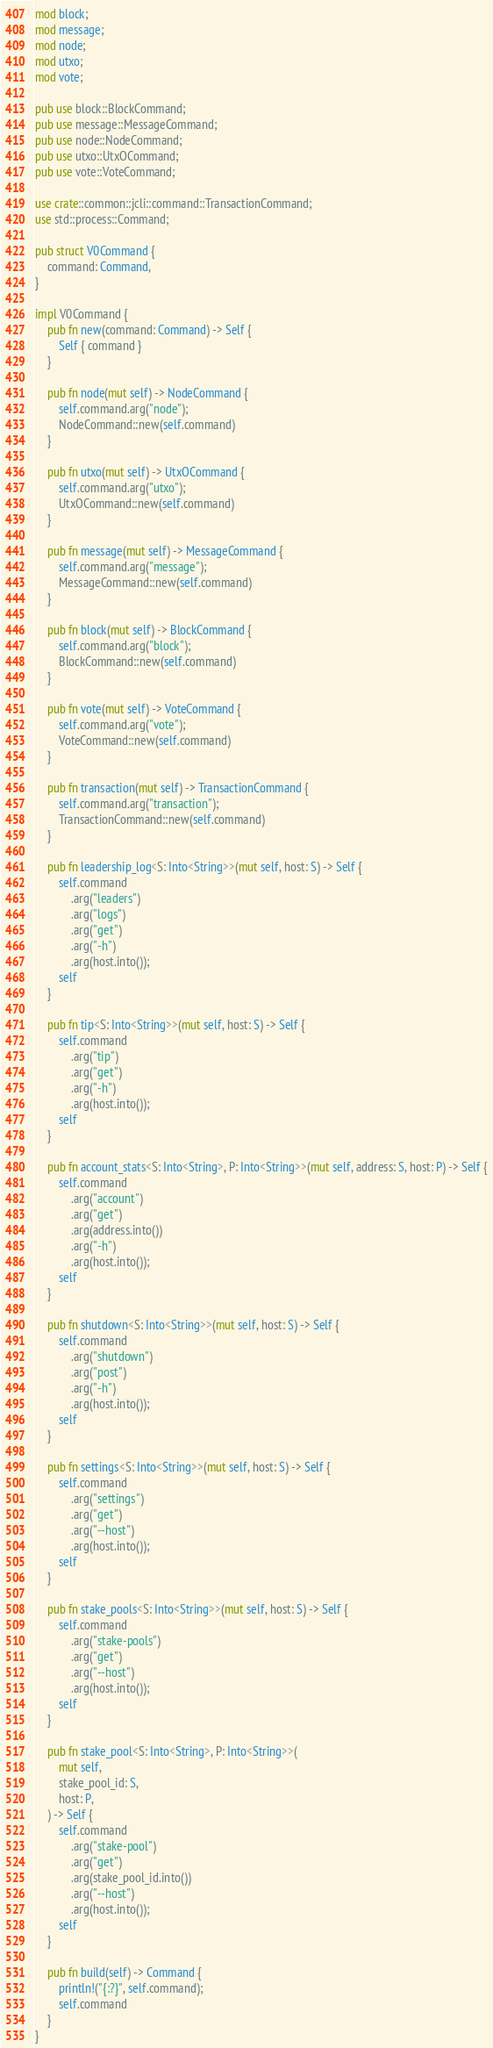Convert code to text. <code><loc_0><loc_0><loc_500><loc_500><_Rust_>mod block;
mod message;
mod node;
mod utxo;
mod vote;

pub use block::BlockCommand;
pub use message::MessageCommand;
pub use node::NodeCommand;
pub use utxo::UtxOCommand;
pub use vote::VoteCommand;

use crate::common::jcli::command::TransactionCommand;
use std::process::Command;

pub struct V0Command {
    command: Command,
}

impl V0Command {
    pub fn new(command: Command) -> Self {
        Self { command }
    }

    pub fn node(mut self) -> NodeCommand {
        self.command.arg("node");
        NodeCommand::new(self.command)
    }

    pub fn utxo(mut self) -> UtxOCommand {
        self.command.arg("utxo");
        UtxOCommand::new(self.command)
    }

    pub fn message(mut self) -> MessageCommand {
        self.command.arg("message");
        MessageCommand::new(self.command)
    }

    pub fn block(mut self) -> BlockCommand {
        self.command.arg("block");
        BlockCommand::new(self.command)
    }

    pub fn vote(mut self) -> VoteCommand {
        self.command.arg("vote");
        VoteCommand::new(self.command)
    }

    pub fn transaction(mut self) -> TransactionCommand {
        self.command.arg("transaction");
        TransactionCommand::new(self.command)
    }

    pub fn leadership_log<S: Into<String>>(mut self, host: S) -> Self {
        self.command
            .arg("leaders")
            .arg("logs")
            .arg("get")
            .arg("-h")
            .arg(host.into());
        self
    }

    pub fn tip<S: Into<String>>(mut self, host: S) -> Self {
        self.command
            .arg("tip")
            .arg("get")
            .arg("-h")
            .arg(host.into());
        self
    }

    pub fn account_stats<S: Into<String>, P: Into<String>>(mut self, address: S, host: P) -> Self {
        self.command
            .arg("account")
            .arg("get")
            .arg(address.into())
            .arg("-h")
            .arg(host.into());
        self
    }

    pub fn shutdown<S: Into<String>>(mut self, host: S) -> Self {
        self.command
            .arg("shutdown")
            .arg("post")
            .arg("-h")
            .arg(host.into());
        self
    }

    pub fn settings<S: Into<String>>(mut self, host: S) -> Self {
        self.command
            .arg("settings")
            .arg("get")
            .arg("--host")
            .arg(host.into());
        self
    }

    pub fn stake_pools<S: Into<String>>(mut self, host: S) -> Self {
        self.command
            .arg("stake-pools")
            .arg("get")
            .arg("--host")
            .arg(host.into());
        self
    }

    pub fn stake_pool<S: Into<String>, P: Into<String>>(
        mut self,
        stake_pool_id: S,
        host: P,
    ) -> Self {
        self.command
            .arg("stake-pool")
            .arg("get")
            .arg(stake_pool_id.into())
            .arg("--host")
            .arg(host.into());
        self
    }

    pub fn build(self) -> Command {
        println!("{:?}", self.command);
        self.command
    }
}
</code> 